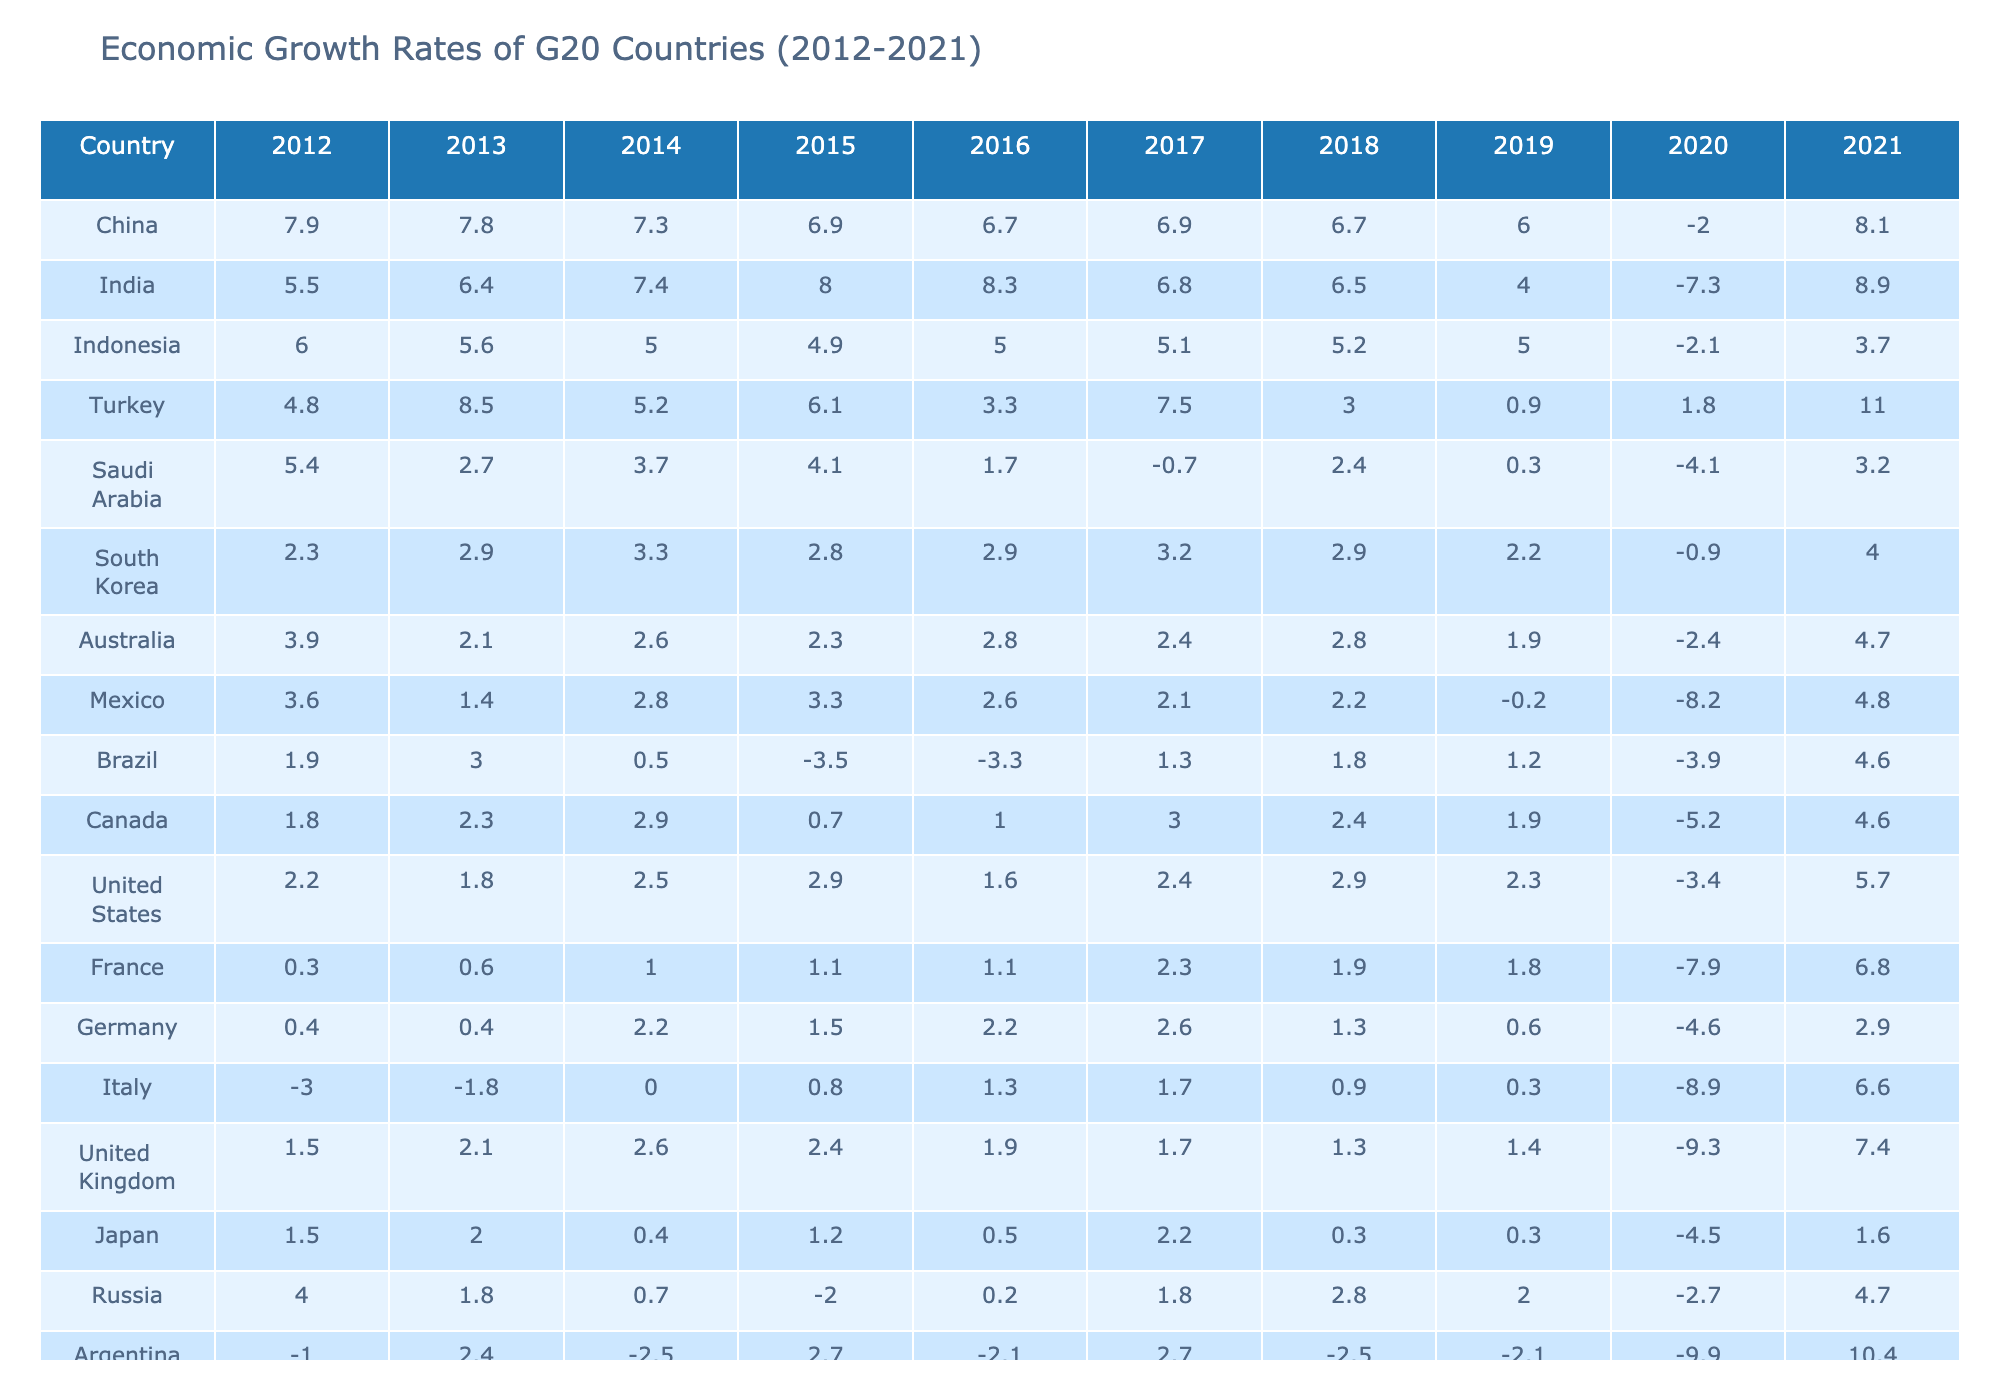What was the economic growth rate of Argentina in 2021? From the table, the economic growth rate for Argentina in 2021 is listed under the corresponding year column. Looking at the row for Argentina and the column for 2021, it shows the value as 10.4.
Answer: 10.4 Which country had the highest economic growth rate in 2019? By examining the 2019 column, the highest value can be identified by scanning through the growth rates of all countries. Turkey, with a growth rate of 0.9, is the highest for that year.
Answer: Turkey What was the average economic growth rate of Canada over the last decade? To find the average, sum the growth rates from 2012 to 2021 (1.8 + 2.3 + 2.9 + 0.7 + 1.0 + 3.0 + 2.4 + 1.9 - 5.2 + 4.6), which totals 12.7, and divide by 10 (the number of years). The average is 12.7/10 = 1.27.
Answer: 1.27 Did South Africa's economy grow every year from 2012 to 2021? Looking through each year from 2012 to 2021, South Africa's rates show fluctuations with a negative growth rate in 2020 (-6.4), indicating that it did not grow every year.
Answer: No What is the percentage increase in the economic growth rate of Turkey from 2020 to 2021? First, identify Turkey's growth rates in 2020 (1.8) and 2021 (11.0). The increase is calculated as (11.0 - 1.8) = 9.2. To find the percentage increase, divide 9.2 by the 2020 value (1.8) and multiply by 100. Thus, (9.2 / 1.8) * 100 ≈ 511.11%.
Answer: Approximately 511.11% Which country showed a decline in economic growth from 2019 to 2020? Check the values in both the 2019 and 2020 columns for each country. Comparing these columns shows that Argentina, India, Indonesia, Mexico, Italy, and the United Kingdom had lower growth rates in 2020 than in 2019, indicating a decline. Specifically, for the United Kingdom, the figure dropped from 1.4 to -9.3.
Answer: Multiple countries, including Argentina and the United Kingdom What was the growth trend of China's economy from 2012 to 2019? Reviewing the growth rates from 2012 (7.9) to 2019 (6.0), one can observe a decreasing trend: 7.9, 7.8, 7.3, 6.9, 6.7, 6.9, 6.7, and finally 6.0. This indicates a consistent decline over the years.
Answer: Declining trend Which country experienced the largest economic contraction in 2020? By examining the 2020 column, the country with the lowest growth rate can be identified, which is Argentina with -9.9. This indicates the largest contraction in that year among all listed countries.
Answer: Argentina Was the economic growth rate of the European Union positive in 2021? Check the 2021 column for the European Union. The growth rate for the EU is listed as 5.4, which is positive, implying growth for that year.
Answer: Yes Which two countries had a growth rate of 4.0 in 2021? Referring to the 2021 column, scan to find which countries share the same growth rate. Both India and South Korea have a rate of 4.0 in that year.
Answer: India and South Korea 